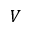Convert formula to latex. <formula><loc_0><loc_0><loc_500><loc_500>V</formula> 